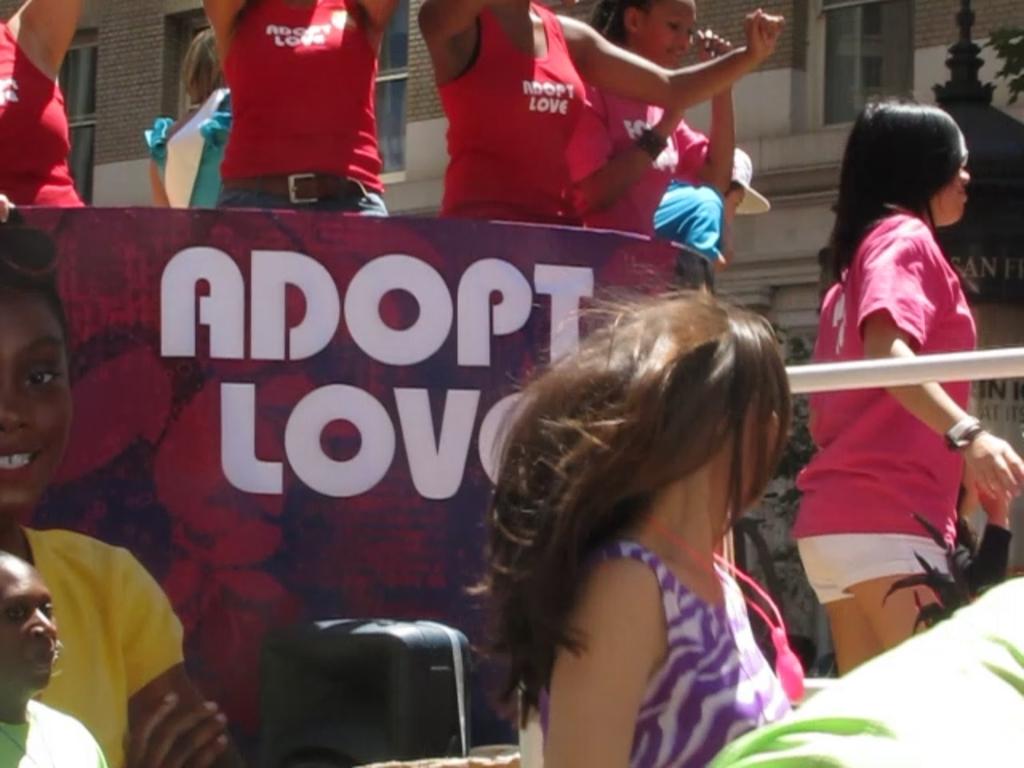What should you adopt?
Give a very brief answer. Love. 